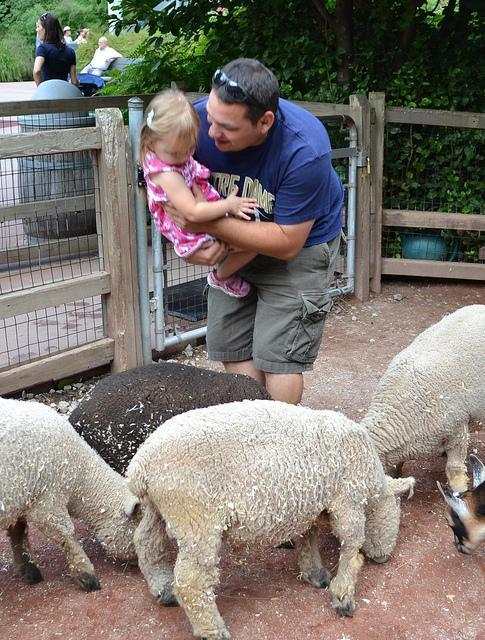How many white sheep is there?
Give a very brief answer. 3. How many sheep can be seen?
Give a very brief answer. 4. How many people are in the photo?
Give a very brief answer. 3. 